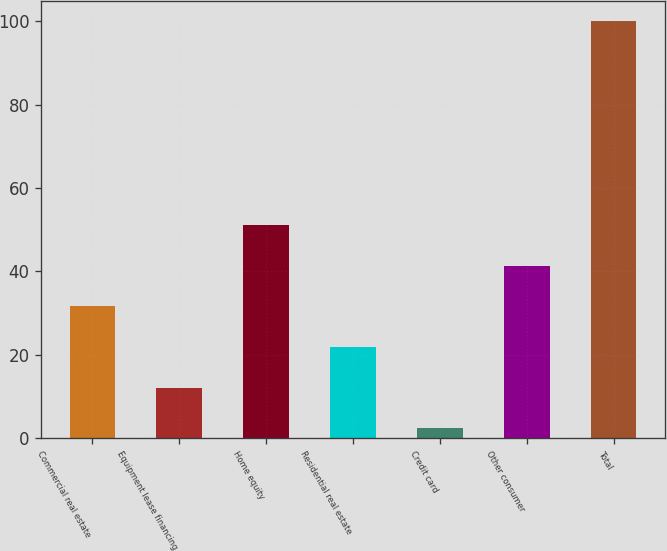Convert chart to OTSL. <chart><loc_0><loc_0><loc_500><loc_500><bar_chart><fcel>Commercial real estate<fcel>Equipment lease financing<fcel>Home equity<fcel>Residential real estate<fcel>Credit card<fcel>Other consumer<fcel>Total<nl><fcel>31.61<fcel>12.07<fcel>51.15<fcel>21.84<fcel>2.3<fcel>41.38<fcel>100<nl></chart> 